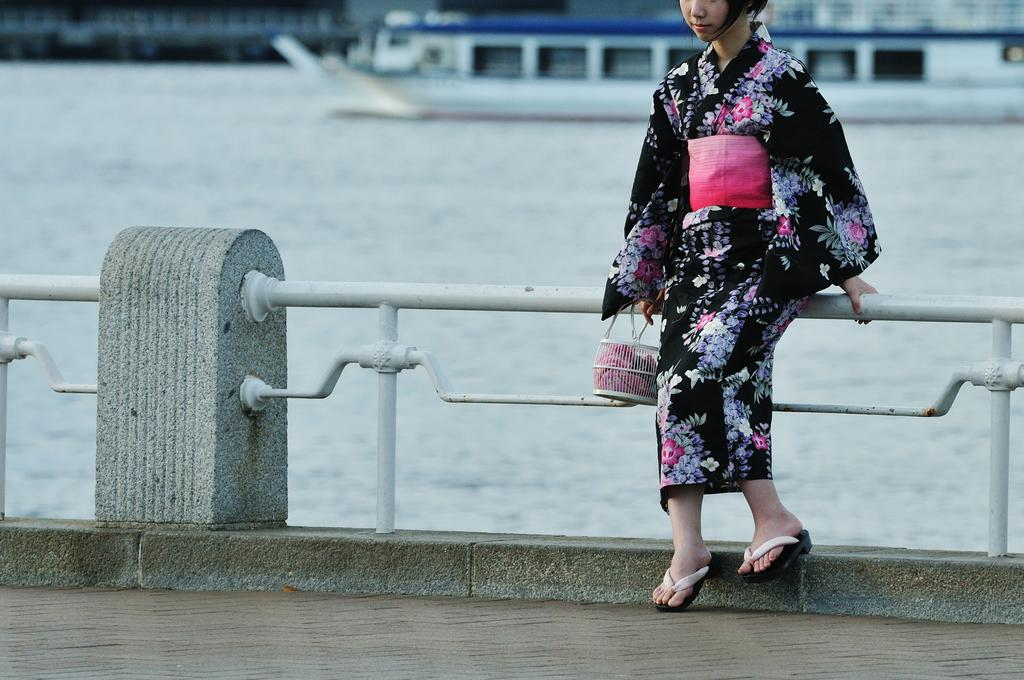Who is present in the image? There is a lady in the image. What can be seen near the lady? There is a railing in the image. What is visible in the background of the image? There is a ship in the background of the image. What type of environment is depicted in the image? There is water visible in the image, suggesting a waterfront or coastal setting. What type of pathway is present in the image? There is a road in the image. How many apples are being used as bait in the image? There are no apples or bait present in the image. 